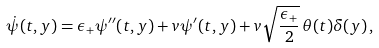<formula> <loc_0><loc_0><loc_500><loc_500>\dot { \psi } ( t , y ) = \epsilon _ { + } \psi ^ { \prime \prime } ( t , y ) + v \psi ^ { \prime } ( t , y ) + v \sqrt { \frac { \epsilon _ { + } } { 2 } } \, \theta ( t ) \delta ( y ) \, ,</formula> 